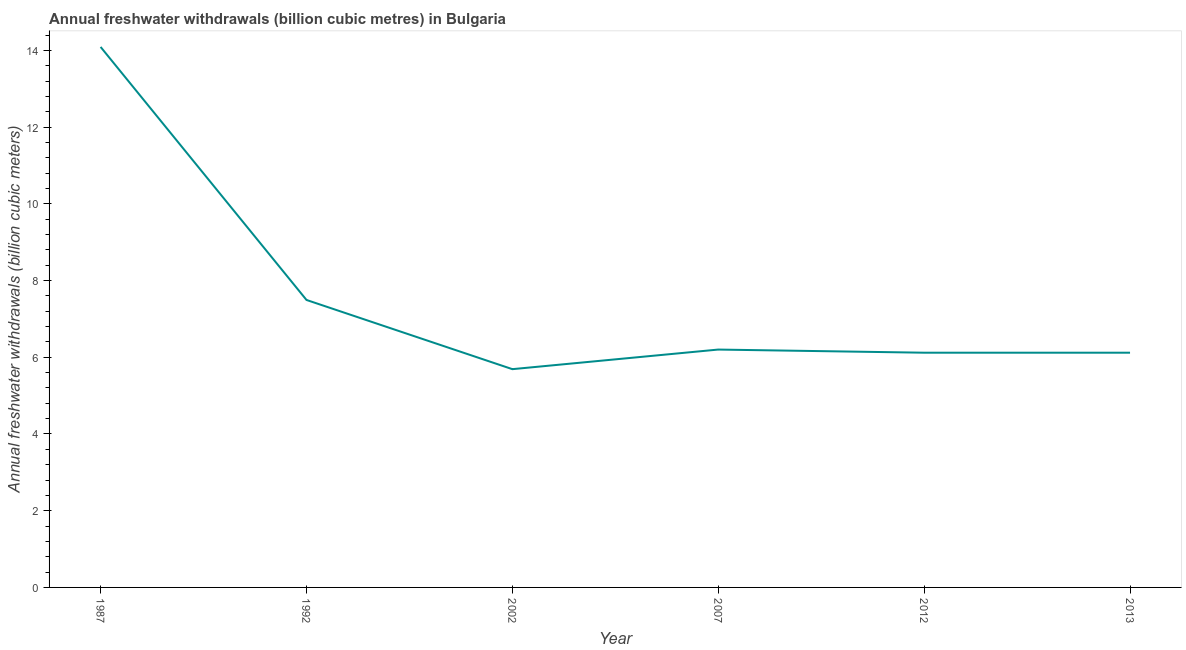What is the annual freshwater withdrawals in 2002?
Your response must be concise. 5.69. Across all years, what is the maximum annual freshwater withdrawals?
Your answer should be compact. 14.09. Across all years, what is the minimum annual freshwater withdrawals?
Offer a terse response. 5.69. In which year was the annual freshwater withdrawals maximum?
Offer a very short reply. 1987. In which year was the annual freshwater withdrawals minimum?
Keep it short and to the point. 2002. What is the sum of the annual freshwater withdrawals?
Give a very brief answer. 45.71. What is the difference between the annual freshwater withdrawals in 1987 and 2012?
Offer a terse response. 7.97. What is the average annual freshwater withdrawals per year?
Provide a short and direct response. 7.62. What is the median annual freshwater withdrawals?
Make the answer very short. 6.16. In how many years, is the annual freshwater withdrawals greater than 5.2 billion cubic meters?
Provide a short and direct response. 6. Do a majority of the years between 2002 and 1992 (inclusive) have annual freshwater withdrawals greater than 3.6 billion cubic meters?
Make the answer very short. No. What is the ratio of the annual freshwater withdrawals in 2002 to that in 2007?
Your answer should be compact. 0.92. Is the difference between the annual freshwater withdrawals in 2002 and 2012 greater than the difference between any two years?
Provide a succinct answer. No. What is the difference between the highest and the second highest annual freshwater withdrawals?
Offer a terse response. 6.6. What is the difference between the highest and the lowest annual freshwater withdrawals?
Offer a very short reply. 8.4. In how many years, is the annual freshwater withdrawals greater than the average annual freshwater withdrawals taken over all years?
Your answer should be very brief. 1. Does the annual freshwater withdrawals monotonically increase over the years?
Give a very brief answer. No. How many years are there in the graph?
Offer a terse response. 6. What is the difference between two consecutive major ticks on the Y-axis?
Keep it short and to the point. 2. What is the title of the graph?
Provide a short and direct response. Annual freshwater withdrawals (billion cubic metres) in Bulgaria. What is the label or title of the Y-axis?
Ensure brevity in your answer.  Annual freshwater withdrawals (billion cubic meters). What is the Annual freshwater withdrawals (billion cubic meters) of 1987?
Your response must be concise. 14.09. What is the Annual freshwater withdrawals (billion cubic meters) of 1992?
Provide a succinct answer. 7.49. What is the Annual freshwater withdrawals (billion cubic meters) of 2002?
Your response must be concise. 5.69. What is the Annual freshwater withdrawals (billion cubic meters) of 2007?
Your response must be concise. 6.2. What is the Annual freshwater withdrawals (billion cubic meters) in 2012?
Provide a succinct answer. 6.12. What is the Annual freshwater withdrawals (billion cubic meters) in 2013?
Provide a succinct answer. 6.12. What is the difference between the Annual freshwater withdrawals (billion cubic meters) in 1987 and 1992?
Make the answer very short. 6.6. What is the difference between the Annual freshwater withdrawals (billion cubic meters) in 1987 and 2002?
Make the answer very short. 8.4. What is the difference between the Annual freshwater withdrawals (billion cubic meters) in 1987 and 2007?
Your answer should be very brief. 7.89. What is the difference between the Annual freshwater withdrawals (billion cubic meters) in 1987 and 2012?
Keep it short and to the point. 7.97. What is the difference between the Annual freshwater withdrawals (billion cubic meters) in 1987 and 2013?
Offer a terse response. 7.97. What is the difference between the Annual freshwater withdrawals (billion cubic meters) in 1992 and 2002?
Give a very brief answer. 1.8. What is the difference between the Annual freshwater withdrawals (billion cubic meters) in 1992 and 2007?
Ensure brevity in your answer.  1.29. What is the difference between the Annual freshwater withdrawals (billion cubic meters) in 1992 and 2012?
Give a very brief answer. 1.38. What is the difference between the Annual freshwater withdrawals (billion cubic meters) in 1992 and 2013?
Give a very brief answer. 1.38. What is the difference between the Annual freshwater withdrawals (billion cubic meters) in 2002 and 2007?
Offer a terse response. -0.51. What is the difference between the Annual freshwater withdrawals (billion cubic meters) in 2002 and 2012?
Ensure brevity in your answer.  -0.43. What is the difference between the Annual freshwater withdrawals (billion cubic meters) in 2002 and 2013?
Offer a terse response. -0.43. What is the difference between the Annual freshwater withdrawals (billion cubic meters) in 2007 and 2012?
Give a very brief answer. 0.08. What is the difference between the Annual freshwater withdrawals (billion cubic meters) in 2007 and 2013?
Your answer should be very brief. 0.08. What is the difference between the Annual freshwater withdrawals (billion cubic meters) in 2012 and 2013?
Give a very brief answer. 0. What is the ratio of the Annual freshwater withdrawals (billion cubic meters) in 1987 to that in 1992?
Keep it short and to the point. 1.88. What is the ratio of the Annual freshwater withdrawals (billion cubic meters) in 1987 to that in 2002?
Offer a terse response. 2.48. What is the ratio of the Annual freshwater withdrawals (billion cubic meters) in 1987 to that in 2007?
Make the answer very short. 2.27. What is the ratio of the Annual freshwater withdrawals (billion cubic meters) in 1987 to that in 2012?
Offer a terse response. 2.3. What is the ratio of the Annual freshwater withdrawals (billion cubic meters) in 1987 to that in 2013?
Offer a very short reply. 2.3. What is the ratio of the Annual freshwater withdrawals (billion cubic meters) in 1992 to that in 2002?
Provide a short and direct response. 1.32. What is the ratio of the Annual freshwater withdrawals (billion cubic meters) in 1992 to that in 2007?
Make the answer very short. 1.21. What is the ratio of the Annual freshwater withdrawals (billion cubic meters) in 1992 to that in 2012?
Ensure brevity in your answer.  1.23. What is the ratio of the Annual freshwater withdrawals (billion cubic meters) in 1992 to that in 2013?
Provide a short and direct response. 1.23. What is the ratio of the Annual freshwater withdrawals (billion cubic meters) in 2002 to that in 2007?
Provide a succinct answer. 0.92. What is the ratio of the Annual freshwater withdrawals (billion cubic meters) in 2002 to that in 2013?
Keep it short and to the point. 0.93. What is the ratio of the Annual freshwater withdrawals (billion cubic meters) in 2007 to that in 2012?
Your answer should be compact. 1.01. 